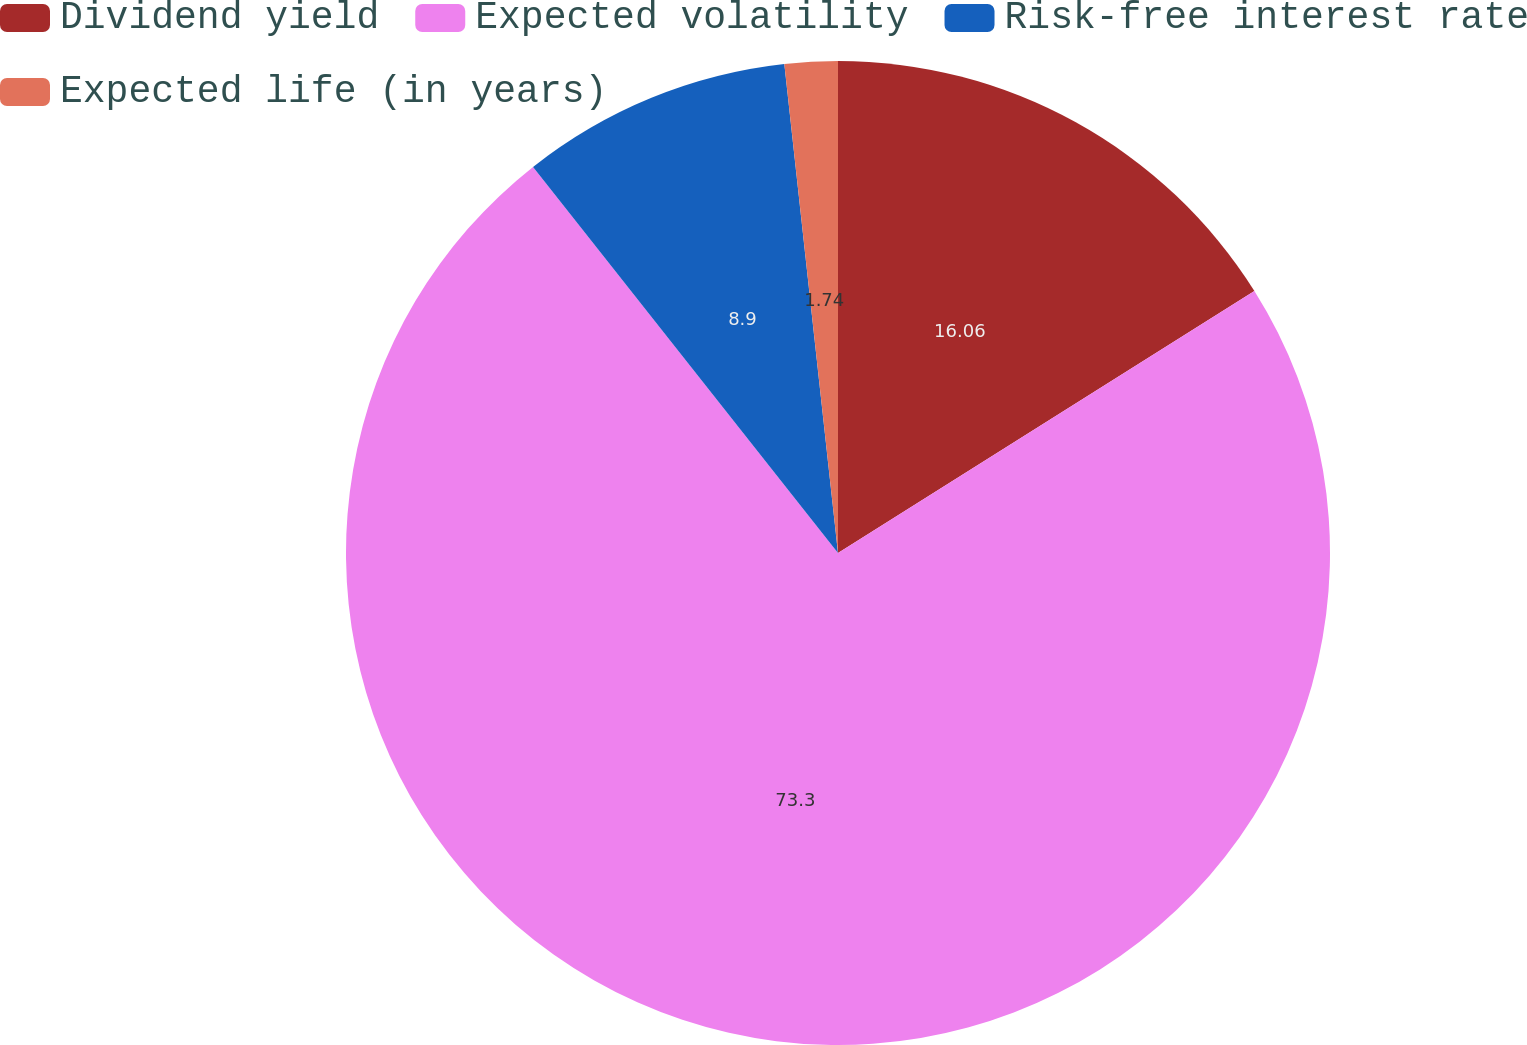Convert chart to OTSL. <chart><loc_0><loc_0><loc_500><loc_500><pie_chart><fcel>Dividend yield<fcel>Expected volatility<fcel>Risk-free interest rate<fcel>Expected life (in years)<nl><fcel>16.06%<fcel>73.3%<fcel>8.9%<fcel>1.74%<nl></chart> 